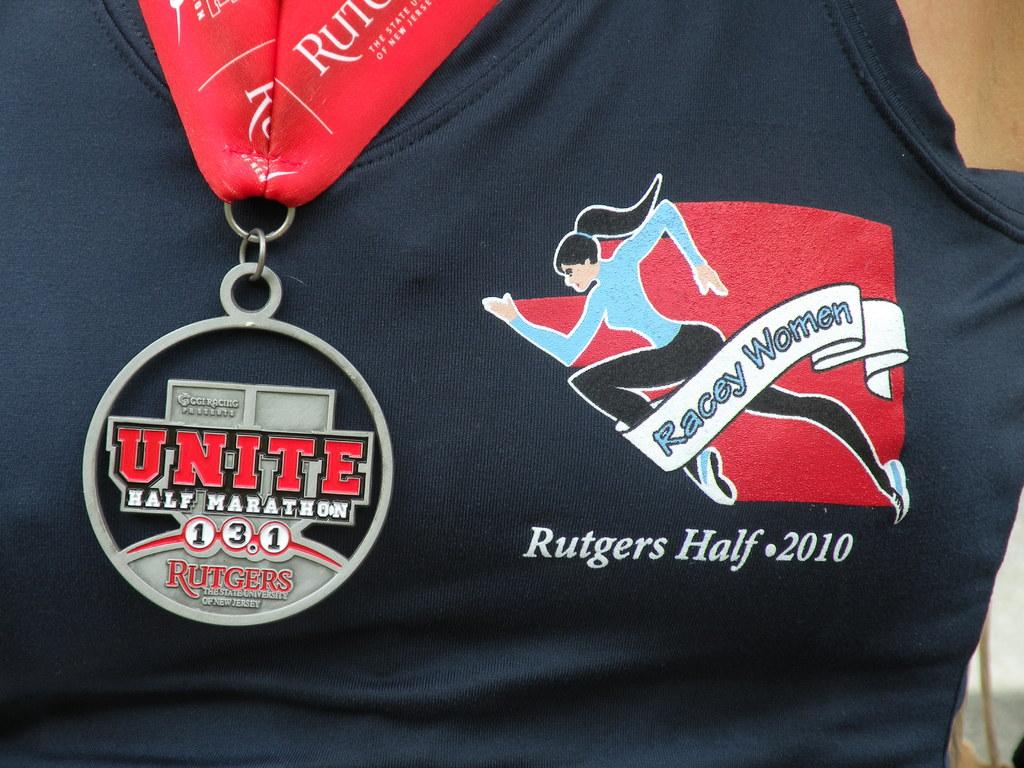Who is sponsoring the marathon?
Your answer should be very brief. Rutgers. What year was this?
Your answer should be very brief. 2010. 